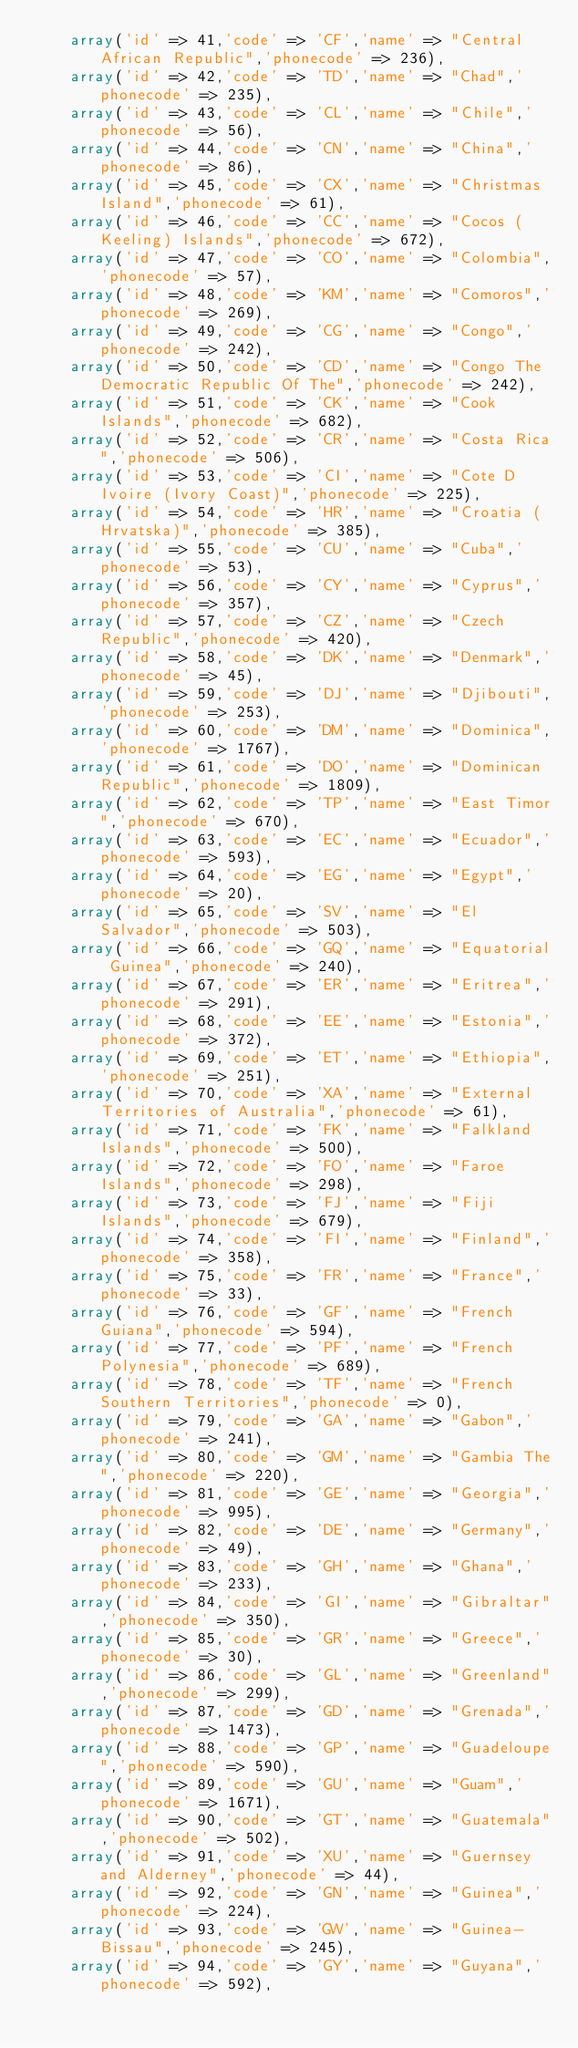Convert code to text. <code><loc_0><loc_0><loc_500><loc_500><_PHP_>		array('id' => 41,'code' => 'CF','name' => "Central African Republic",'phonecode' => 236),
		array('id' => 42,'code' => 'TD','name' => "Chad",'phonecode' => 235),
		array('id' => 43,'code' => 'CL','name' => "Chile",'phonecode' => 56),
		array('id' => 44,'code' => 'CN','name' => "China",'phonecode' => 86),
		array('id' => 45,'code' => 'CX','name' => "Christmas Island",'phonecode' => 61),
		array('id' => 46,'code' => 'CC','name' => "Cocos (Keeling) Islands",'phonecode' => 672),
		array('id' => 47,'code' => 'CO','name' => "Colombia",'phonecode' => 57),
		array('id' => 48,'code' => 'KM','name' => "Comoros",'phonecode' => 269),
		array('id' => 49,'code' => 'CG','name' => "Congo",'phonecode' => 242),
		array('id' => 50,'code' => 'CD','name' => "Congo The Democratic Republic Of The",'phonecode' => 242),
		array('id' => 51,'code' => 'CK','name' => "Cook Islands",'phonecode' => 682),
		array('id' => 52,'code' => 'CR','name' => "Costa Rica",'phonecode' => 506),
		array('id' => 53,'code' => 'CI','name' => "Cote D Ivoire (Ivory Coast)",'phonecode' => 225),
		array('id' => 54,'code' => 'HR','name' => "Croatia (Hrvatska)",'phonecode' => 385),
		array('id' => 55,'code' => 'CU','name' => "Cuba",'phonecode' => 53),
		array('id' => 56,'code' => 'CY','name' => "Cyprus",'phonecode' => 357),
		array('id' => 57,'code' => 'CZ','name' => "Czech Republic",'phonecode' => 420),
		array('id' => 58,'code' => 'DK','name' => "Denmark",'phonecode' => 45),
		array('id' => 59,'code' => 'DJ','name' => "Djibouti",'phonecode' => 253),
		array('id' => 60,'code' => 'DM','name' => "Dominica",'phonecode' => 1767),
		array('id' => 61,'code' => 'DO','name' => "Dominican Republic",'phonecode' => 1809),
		array('id' => 62,'code' => 'TP','name' => "East Timor",'phonecode' => 670),
		array('id' => 63,'code' => 'EC','name' => "Ecuador",'phonecode' => 593),
		array('id' => 64,'code' => 'EG','name' => "Egypt",'phonecode' => 20),
		array('id' => 65,'code' => 'SV','name' => "El Salvador",'phonecode' => 503),
		array('id' => 66,'code' => 'GQ','name' => "Equatorial Guinea",'phonecode' => 240),
		array('id' => 67,'code' => 'ER','name' => "Eritrea",'phonecode' => 291),
		array('id' => 68,'code' => 'EE','name' => "Estonia",'phonecode' => 372),
		array('id' => 69,'code' => 'ET','name' => "Ethiopia",'phonecode' => 251),
		array('id' => 70,'code' => 'XA','name' => "External Territories of Australia",'phonecode' => 61),
		array('id' => 71,'code' => 'FK','name' => "Falkland Islands",'phonecode' => 500),
		array('id' => 72,'code' => 'FO','name' => "Faroe Islands",'phonecode' => 298),
		array('id' => 73,'code' => 'FJ','name' => "Fiji Islands",'phonecode' => 679),
		array('id' => 74,'code' => 'FI','name' => "Finland",'phonecode' => 358),
		array('id' => 75,'code' => 'FR','name' => "France",'phonecode' => 33),
		array('id' => 76,'code' => 'GF','name' => "French Guiana",'phonecode' => 594),
		array('id' => 77,'code' => 'PF','name' => "French Polynesia",'phonecode' => 689),
		array('id' => 78,'code' => 'TF','name' => "French Southern Territories",'phonecode' => 0),
		array('id' => 79,'code' => 'GA','name' => "Gabon",'phonecode' => 241),
		array('id' => 80,'code' => 'GM','name' => "Gambia The",'phonecode' => 220),
		array('id' => 81,'code' => 'GE','name' => "Georgia",'phonecode' => 995),
		array('id' => 82,'code' => 'DE','name' => "Germany",'phonecode' => 49),
		array('id' => 83,'code' => 'GH','name' => "Ghana",'phonecode' => 233),
		array('id' => 84,'code' => 'GI','name' => "Gibraltar",'phonecode' => 350),
		array('id' => 85,'code' => 'GR','name' => "Greece",'phonecode' => 30),
		array('id' => 86,'code' => 'GL','name' => "Greenland",'phonecode' => 299),
		array('id' => 87,'code' => 'GD','name' => "Grenada",'phonecode' => 1473),
		array('id' => 88,'code' => 'GP','name' => "Guadeloupe",'phonecode' => 590),
		array('id' => 89,'code' => 'GU','name' => "Guam",'phonecode' => 1671),
		array('id' => 90,'code' => 'GT','name' => "Guatemala",'phonecode' => 502),
		array('id' => 91,'code' => 'XU','name' => "Guernsey and Alderney",'phonecode' => 44),
		array('id' => 92,'code' => 'GN','name' => "Guinea",'phonecode' => 224),
		array('id' => 93,'code' => 'GW','name' => "Guinea-Bissau",'phonecode' => 245),
		array('id' => 94,'code' => 'GY','name' => "Guyana",'phonecode' => 592),</code> 